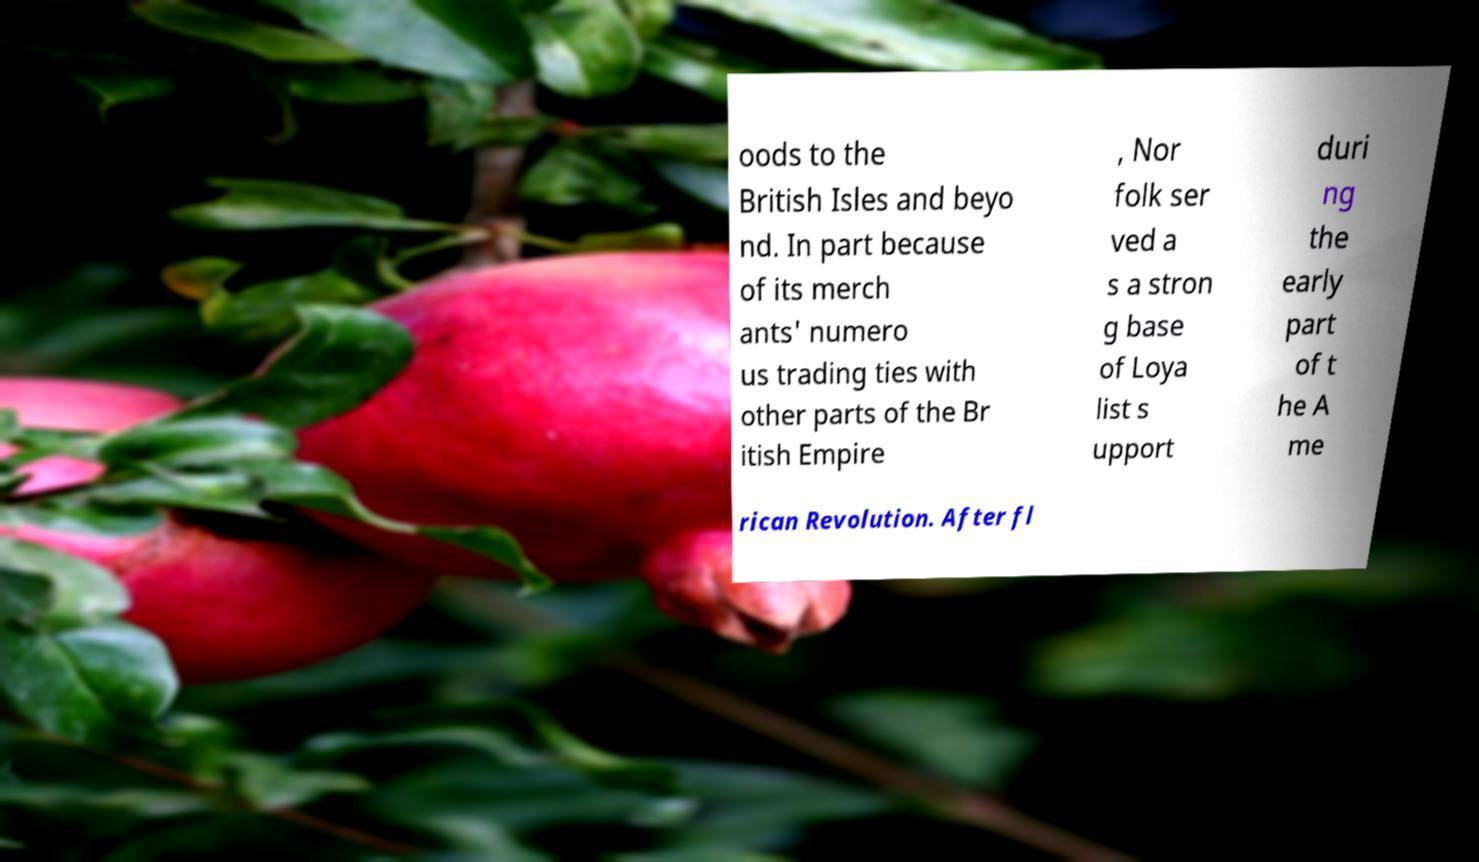Could you extract and type out the text from this image? oods to the British Isles and beyo nd. In part because of its merch ants' numero us trading ties with other parts of the Br itish Empire , Nor folk ser ved a s a stron g base of Loya list s upport duri ng the early part of t he A me rican Revolution. After fl 